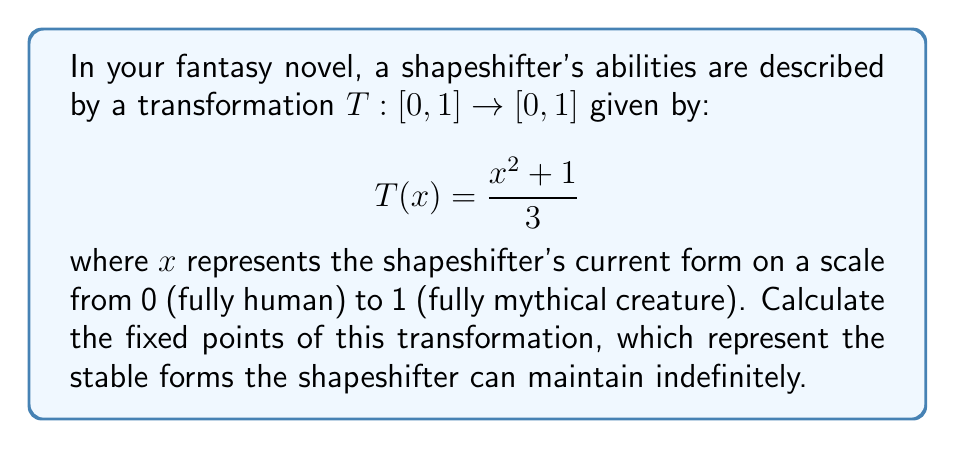Show me your answer to this math problem. To find the fixed points of the transformation, we need to solve the equation $T(x) = x$. This means we're looking for values of $x$ where the shapeshifter's form remains unchanged after applying the transformation.

1) Set up the equation:
   $$\frac{x^2 + 1}{3} = x$$

2) Multiply both sides by 3:
   $$x^2 + 1 = 3x$$

3) Rearrange to standard quadratic form:
   $$x^2 - 3x + 1 = 0$$

4) Use the quadratic formula: $x = \frac{-b \pm \sqrt{b^2 - 4ac}}{2a}$
   Where $a=1$, $b=-3$, and $c=1$

5) Substitute into the quadratic formula:
   $$x = \frac{3 \pm \sqrt{9 - 4}}{2} = \frac{3 \pm \sqrt{5}}{2}$$

6) Simplify:
   $$x_1 = \frac{3 + \sqrt{5}}{2} \approx 2.618$$
   $$x_2 = \frac{3 - \sqrt{5}}{2} \approx 0.382$$

7) Check if both solutions are in the domain [0,1]:
   $x_1 > 1$, so it's not a valid fixed point.
   $0 < x_2 < 1$, so it is a valid fixed point.

Therefore, the only fixed point in the given domain is $\frac{3 - \sqrt{5}}{2}$.
Answer: The fixed point of the transformation is $\frac{3 - \sqrt{5}}{2} \approx 0.382$. 